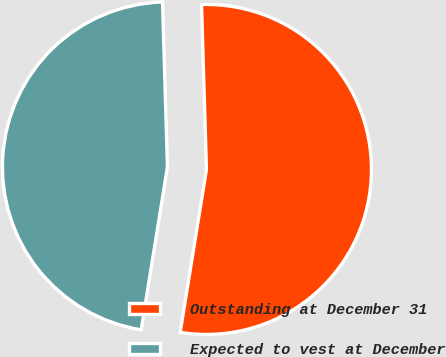Convert chart. <chart><loc_0><loc_0><loc_500><loc_500><pie_chart><fcel>Outstanding at December 31<fcel>Expected to vest at December<nl><fcel>53.02%<fcel>46.98%<nl></chart> 